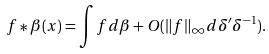Convert formula to latex. <formula><loc_0><loc_0><loc_500><loc_500>f \ast \beta ( x ) = \int { f d \beta } + O ( \| f \| _ { \infty } d \delta ^ { \prime } \delta ^ { - 1 } ) .</formula> 